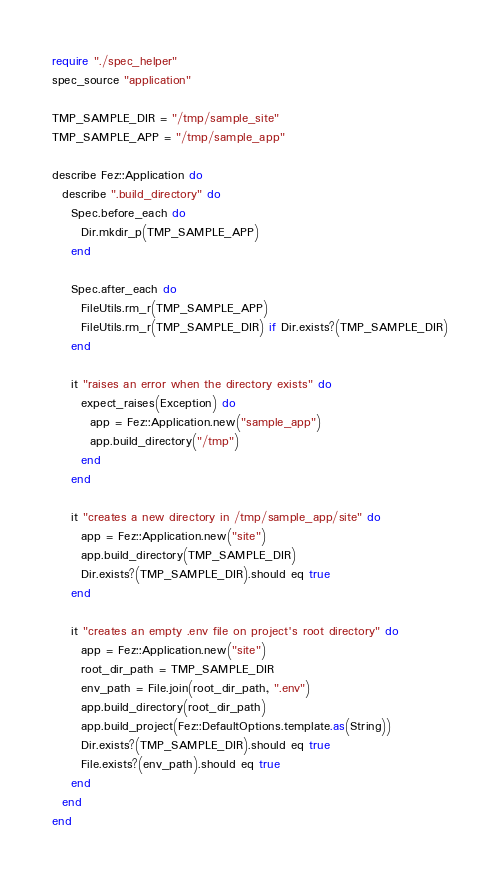Convert code to text. <code><loc_0><loc_0><loc_500><loc_500><_Crystal_>require "./spec_helper"
spec_source "application"

TMP_SAMPLE_DIR = "/tmp/sample_site"
TMP_SAMPLE_APP = "/tmp/sample_app"

describe Fez::Application do
  describe ".build_directory" do
    Spec.before_each do
      Dir.mkdir_p(TMP_SAMPLE_APP)
    end

    Spec.after_each do
      FileUtils.rm_r(TMP_SAMPLE_APP)
      FileUtils.rm_r(TMP_SAMPLE_DIR) if Dir.exists?(TMP_SAMPLE_DIR)
    end

    it "raises an error when the directory exists" do
      expect_raises(Exception) do
        app = Fez::Application.new("sample_app")
        app.build_directory("/tmp")
      end
    end

    it "creates a new directory in /tmp/sample_app/site" do
      app = Fez::Application.new("site")
      app.build_directory(TMP_SAMPLE_DIR)
      Dir.exists?(TMP_SAMPLE_DIR).should eq true
    end

    it "creates an empty .env file on project's root directory" do
      app = Fez::Application.new("site")
      root_dir_path = TMP_SAMPLE_DIR
      env_path = File.join(root_dir_path, ".env")
      app.build_directory(root_dir_path)
      app.build_project(Fez::DefaultOptions.template.as(String))
      Dir.exists?(TMP_SAMPLE_DIR).should eq true
      File.exists?(env_path).should eq true
    end
  end
end
</code> 